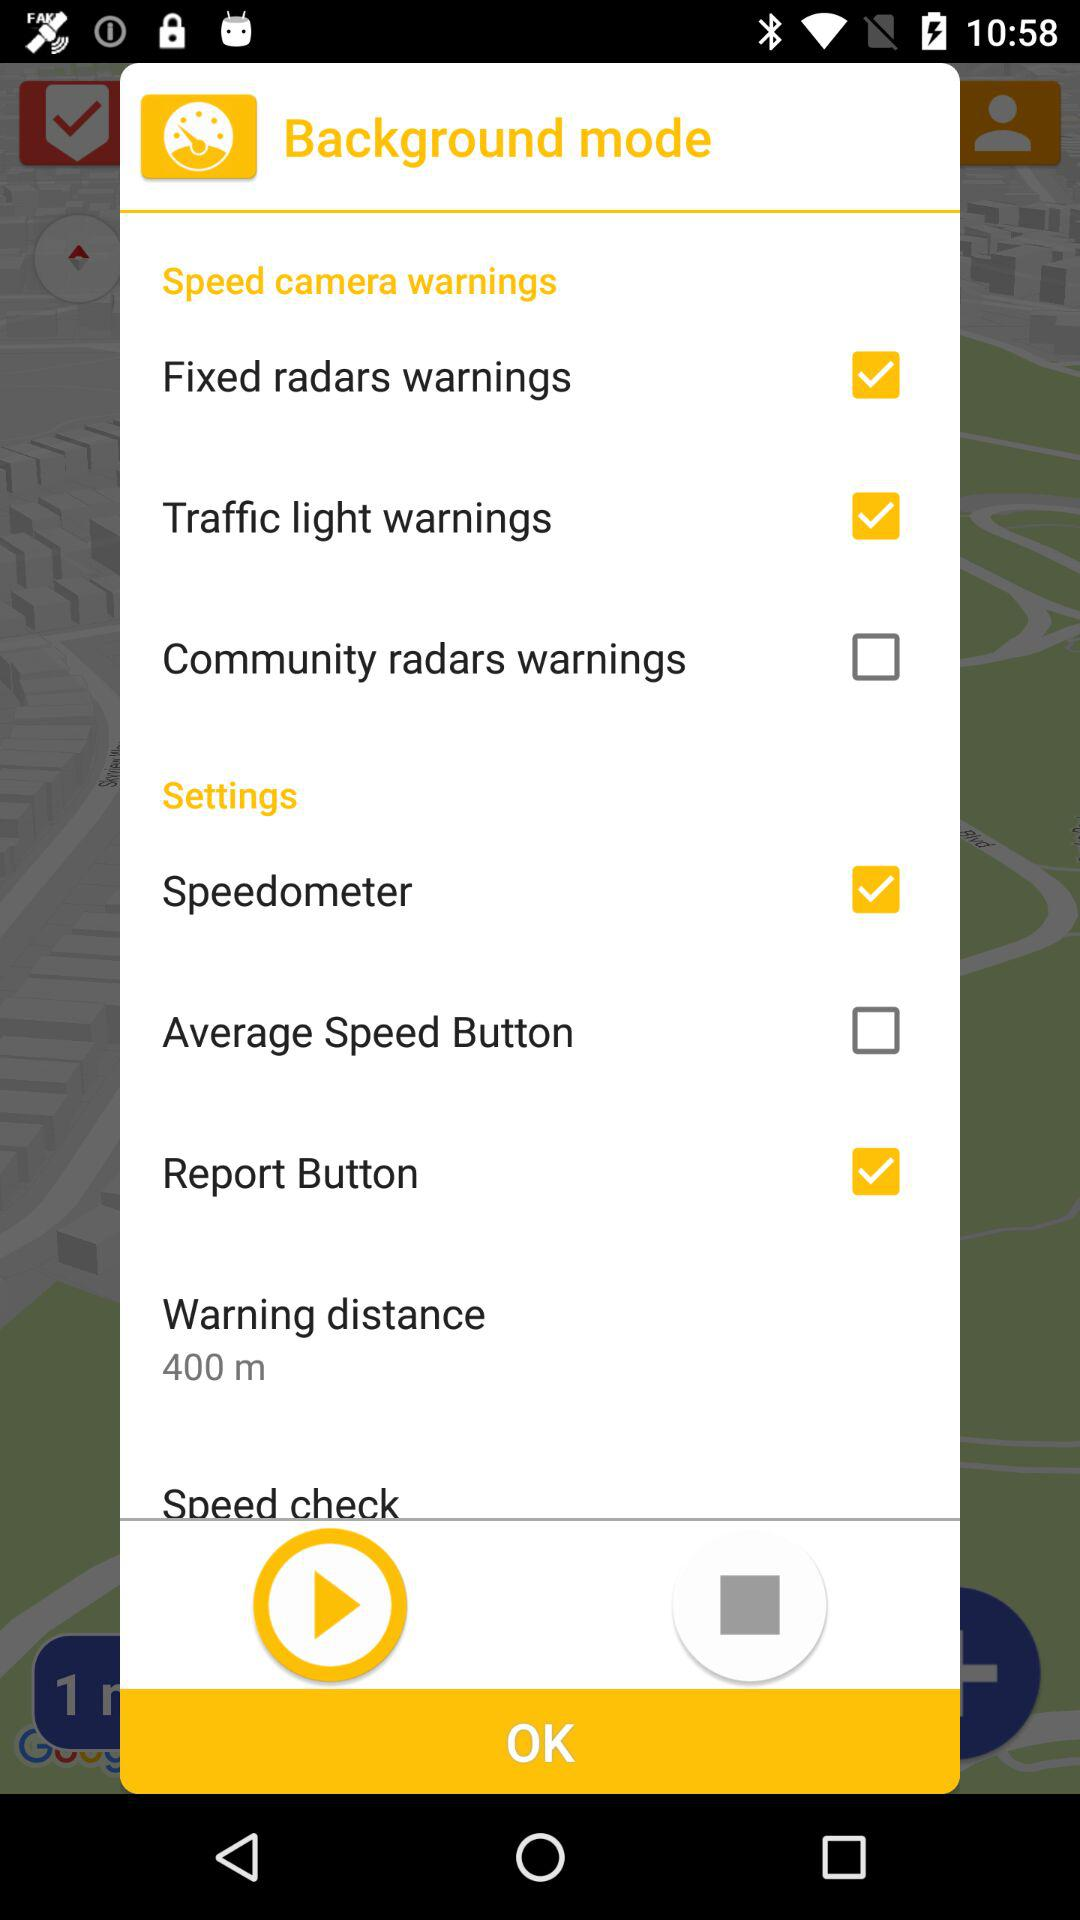What is the "Warning distance"? The "Warning distance" is 400 m. 